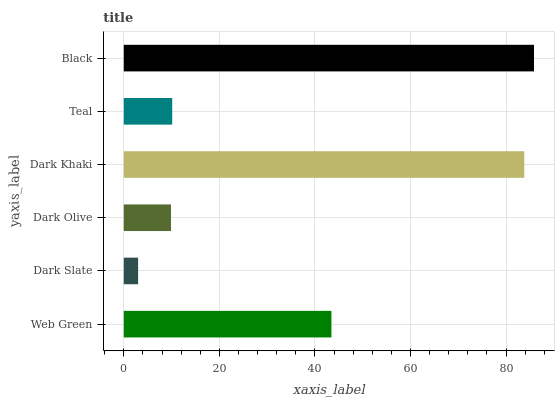Is Dark Slate the minimum?
Answer yes or no. Yes. Is Black the maximum?
Answer yes or no. Yes. Is Dark Olive the minimum?
Answer yes or no. No. Is Dark Olive the maximum?
Answer yes or no. No. Is Dark Olive greater than Dark Slate?
Answer yes or no. Yes. Is Dark Slate less than Dark Olive?
Answer yes or no. Yes. Is Dark Slate greater than Dark Olive?
Answer yes or no. No. Is Dark Olive less than Dark Slate?
Answer yes or no. No. Is Web Green the high median?
Answer yes or no. Yes. Is Teal the low median?
Answer yes or no. Yes. Is Dark Olive the high median?
Answer yes or no. No. Is Black the low median?
Answer yes or no. No. 